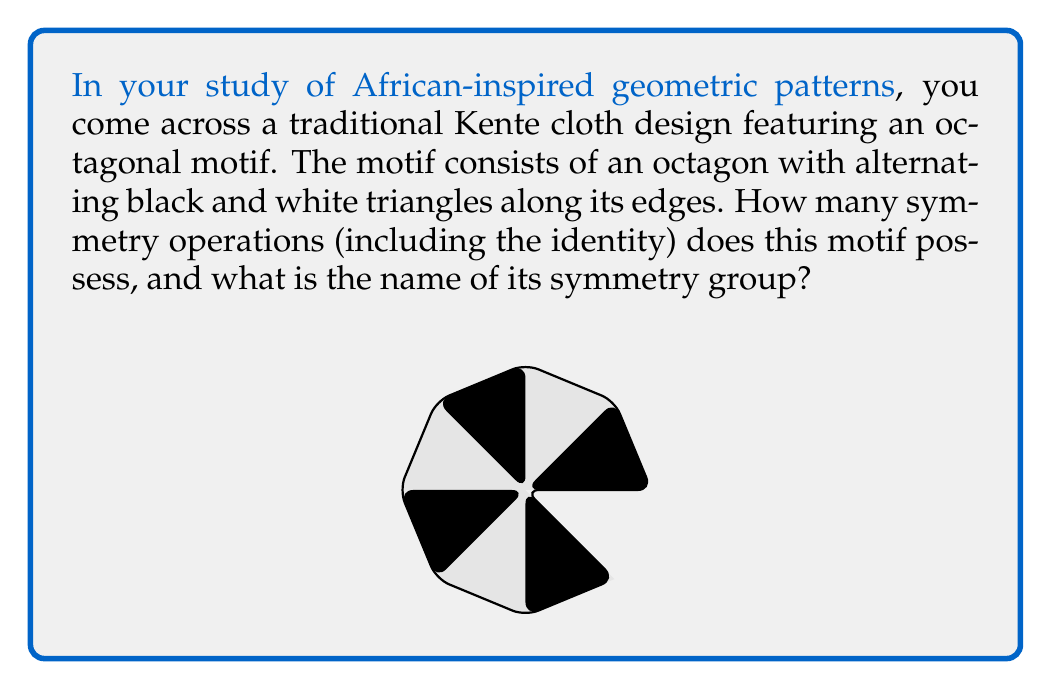Show me your answer to this math problem. To analyze the symmetry group of this African-inspired octagonal motif, we need to identify all the symmetry operations that leave the pattern unchanged. Let's break this down step-by-step:

1. Rotational symmetry:
   The pattern has 8-fold rotational symmetry. It remains unchanged when rotated by multiples of 45°. This gives us 8 rotational symmetries (including the identity rotation of 0°).

2. Reflection symmetry:
   There are two types of reflection axes:
   a) 4 axes through opposite vertices
   b) 4 axes through the midpoints of opposite sides
   This gives us 8 reflection symmetries.

3. Identity:
   The identity transformation (doing nothing) is always a symmetry.

In total, we have 8 (rotations) + 8 (reflections) + 1 (identity) = 17 symmetry operations.

The symmetry group that describes this pattern is the dihedral group $D_8$. In general, the dihedral group $D_n$ describes the symmetries of a regular n-gon, and has order $2n$.

To verify:
$$|D_8| = 2 \cdot 8 = 16 + 1 \text{ (identity) } = 17$$

This group is non-abelian, as rotations and reflections do not generally commute.

The significance of this symmetry group in the context of African design lies in its representation of balance, harmony, and the cyclical nature of life often depicted in traditional African art and textiles.
Answer: The octagonal motif possesses 17 symmetry operations, and its symmetry group is $D_8$ (the dihedral group of order 16, plus the identity). 